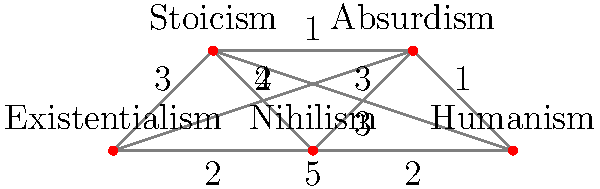In the philosophical network shown above, each node represents a school of thought, and the edges represent the conceptual distance between them. What is the shortest path from Existentialism to Humanism, and what is its total length? To find the shortest path from Existentialism to Humanism, we need to consider all possible paths and their lengths:

1. Existentialism → Humanism (direct): Length 5
2. Existentialism → Stoicism → Humanism: Length 3 + 3 = 6
3. Existentialism → Nihilism → Humanism: Length 2 + 2 = 4
4. Existentialism → Absurdism → Humanism: Length 4 + 1 = 5
5. Existentialism → Stoicism → Absurdism → Humanism: Length 3 + 1 + 1 = 5
6. Existentialism → Nihilism → Absurdism → Humanism: Length 2 + 3 + 1 = 6

The shortest path is Existentialism → Nihilism → Humanism, with a total length of 4.

This path reflects the philosophical progression from Existentialism's focus on individual existence to Nihilism's rejection of inherent meaning, and finally to Humanism's emphasis on human values and agency without relying on external sources of meaning.
Answer: Existentialism → Nihilism → Humanism, length 4 